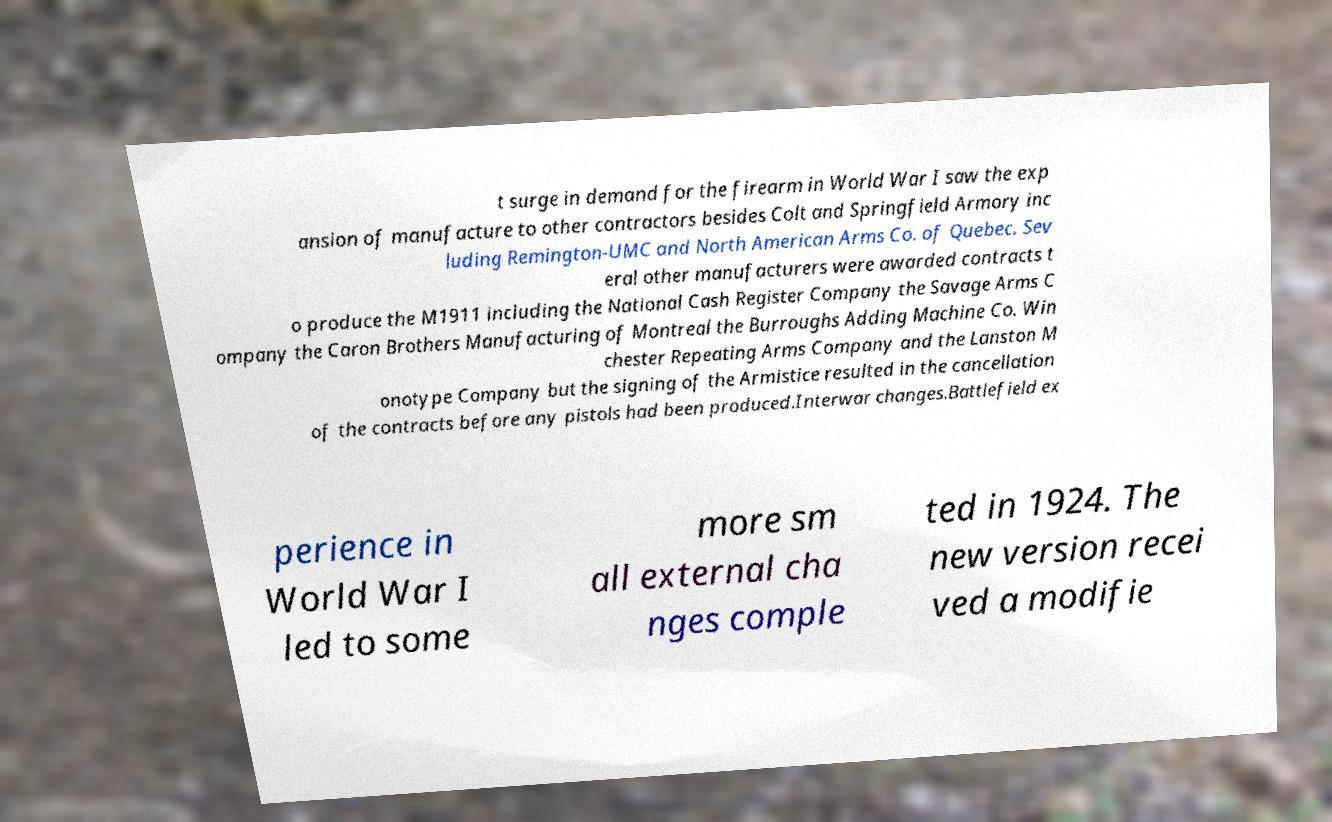For documentation purposes, I need the text within this image transcribed. Could you provide that? t surge in demand for the firearm in World War I saw the exp ansion of manufacture to other contractors besides Colt and Springfield Armory inc luding Remington-UMC and North American Arms Co. of Quebec. Sev eral other manufacturers were awarded contracts t o produce the M1911 including the National Cash Register Company the Savage Arms C ompany the Caron Brothers Manufacturing of Montreal the Burroughs Adding Machine Co. Win chester Repeating Arms Company and the Lanston M onotype Company but the signing of the Armistice resulted in the cancellation of the contracts before any pistols had been produced.Interwar changes.Battlefield ex perience in World War I led to some more sm all external cha nges comple ted in 1924. The new version recei ved a modifie 